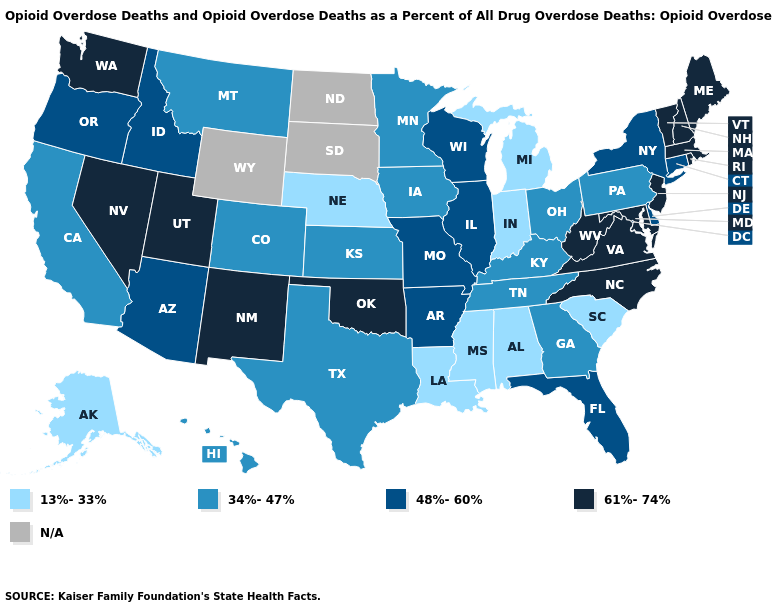Among the states that border Texas , which have the lowest value?
Be succinct. Louisiana. Among the states that border Connecticut , does New York have the lowest value?
Write a very short answer. Yes. Does Arkansas have the lowest value in the USA?
Be succinct. No. What is the lowest value in the Northeast?
Concise answer only. 34%-47%. Which states hav the highest value in the MidWest?
Keep it brief. Illinois, Missouri, Wisconsin. Does Nebraska have the lowest value in the MidWest?
Concise answer only. Yes. Does the map have missing data?
Be succinct. Yes. Does the first symbol in the legend represent the smallest category?
Answer briefly. Yes. Which states have the lowest value in the USA?
Answer briefly. Alabama, Alaska, Indiana, Louisiana, Michigan, Mississippi, Nebraska, South Carolina. What is the highest value in the West ?
Be succinct. 61%-74%. What is the value of Alabama?
Give a very brief answer. 13%-33%. Does the first symbol in the legend represent the smallest category?
Give a very brief answer. Yes. 